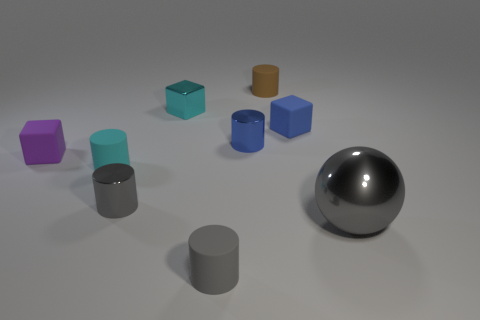Subtract all small purple matte cubes. How many cubes are left? 2 Subtract all purple cubes. How many cubes are left? 2 Subtract all spheres. How many objects are left? 8 Add 5 small blue metal cylinders. How many small blue metal cylinders exist? 6 Subtract 0 brown spheres. How many objects are left? 9 Subtract 1 balls. How many balls are left? 0 Subtract all red cubes. Subtract all brown cylinders. How many cubes are left? 3 Subtract all yellow blocks. How many blue cylinders are left? 1 Subtract all purple rubber things. Subtract all tiny gray shiny cylinders. How many objects are left? 7 Add 8 gray shiny things. How many gray shiny things are left? 10 